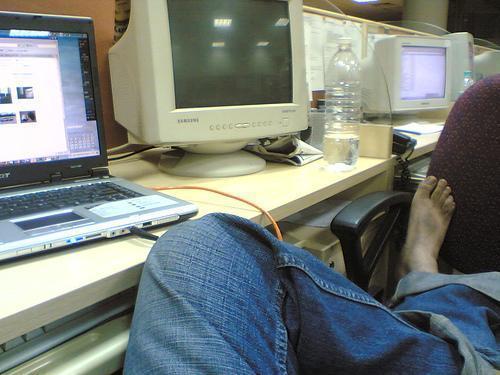How many laptops do you see?
Give a very brief answer. 1. How many laptops are in the photo?
Give a very brief answer. 1. How many tvs are in the picture?
Give a very brief answer. 2. How many people are wearing orange shirts?
Give a very brief answer. 0. 